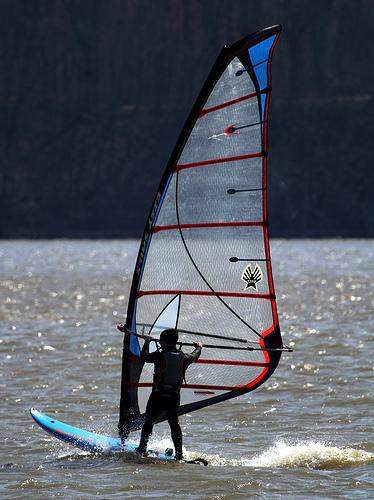Question: where was the picture taken?
Choices:
A. By the store.
B. At a lake.
C. Next to a pond.
D. At the animal shelter.
Answer with the letter. Answer: B Question: what color is the sailboat?
Choices:
A. Blue.
B. Red.
C. Green.
D. Black.
Answer with the letter. Answer: A Question: what is the person on?
Choices:
A. The dock.
B. The sailboat.
C. The beach.
D. The canoe.
Answer with the letter. Answer: B Question: what is the sailboat on?
Choices:
A. The water.
B. The dry dock.
C. The flatbed trailer.
D. The freight train.
Answer with the letter. Answer: A 